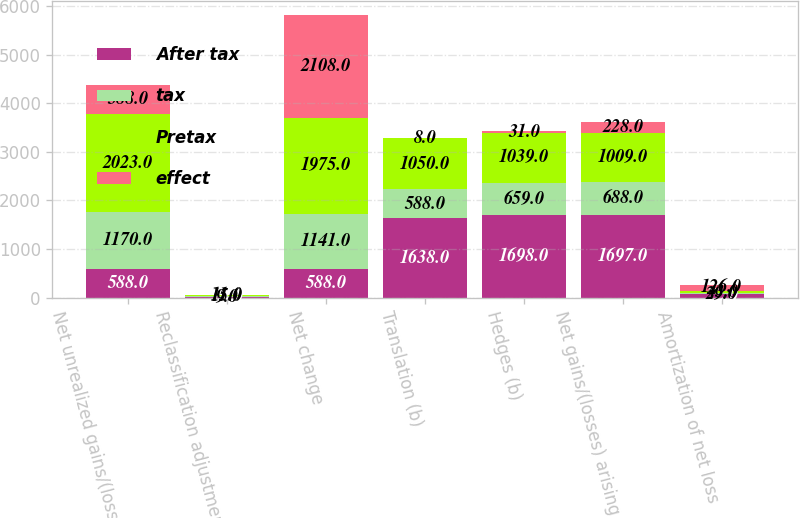Convert chart to OTSL. <chart><loc_0><loc_0><loc_500><loc_500><stacked_bar_chart><ecel><fcel>Net unrealized gains/(losses)<fcel>Reclassification adjustment<fcel>Net change<fcel>Translation (b)<fcel>Hedges (b)<fcel>Net gains/(losses) arising<fcel>Amortization of net loss<nl><fcel>After tax<fcel>588<fcel>24<fcel>588<fcel>1638<fcel>1698<fcel>1697<fcel>72<nl><fcel>tax<fcel>1170<fcel>9<fcel>1141<fcel>588<fcel>659<fcel>688<fcel>29<nl><fcel>Pretax<fcel>2023<fcel>15<fcel>1975<fcel>1050<fcel>1039<fcel>1009<fcel>43<nl><fcel>effect<fcel>588<fcel>11<fcel>2108<fcel>8<fcel>31<fcel>228<fcel>126<nl></chart> 